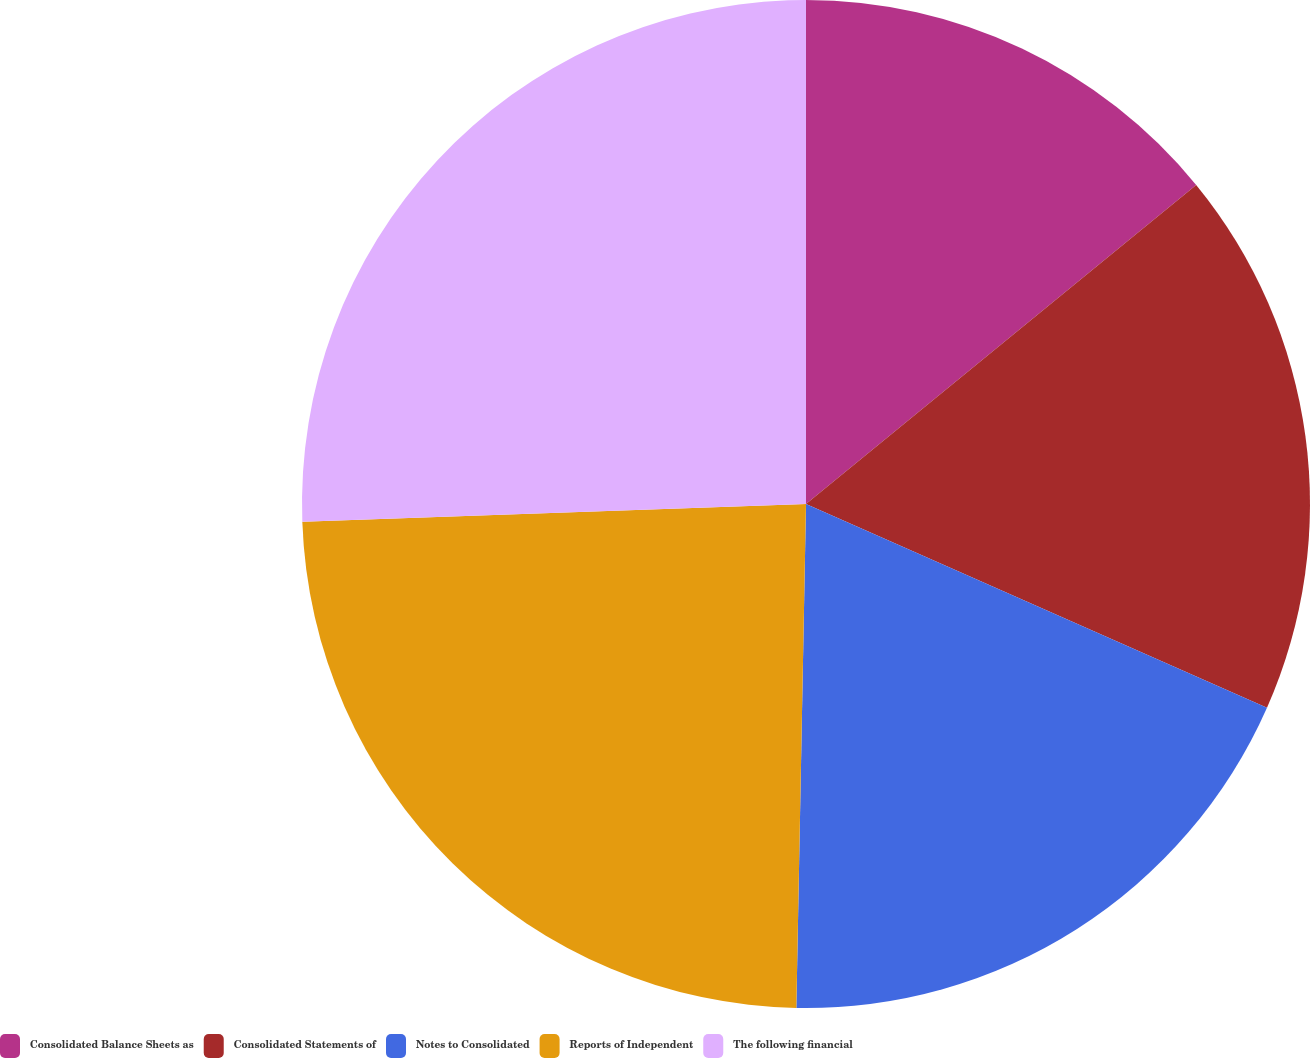Convert chart to OTSL. <chart><loc_0><loc_0><loc_500><loc_500><pie_chart><fcel>Consolidated Balance Sheets as<fcel>Consolidated Statements of<fcel>Notes to Consolidated<fcel>Reports of Independent<fcel>The following financial<nl><fcel>14.09%<fcel>17.53%<fcel>18.68%<fcel>24.13%<fcel>25.56%<nl></chart> 